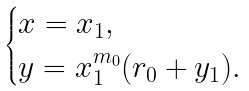Convert formula to latex. <formula><loc_0><loc_0><loc_500><loc_500>\begin{cases} x = x _ { 1 } , \\ y = x _ { 1 } ^ { m _ { 0 } } ( r _ { 0 } + y _ { 1 } ) . \end{cases}</formula> 